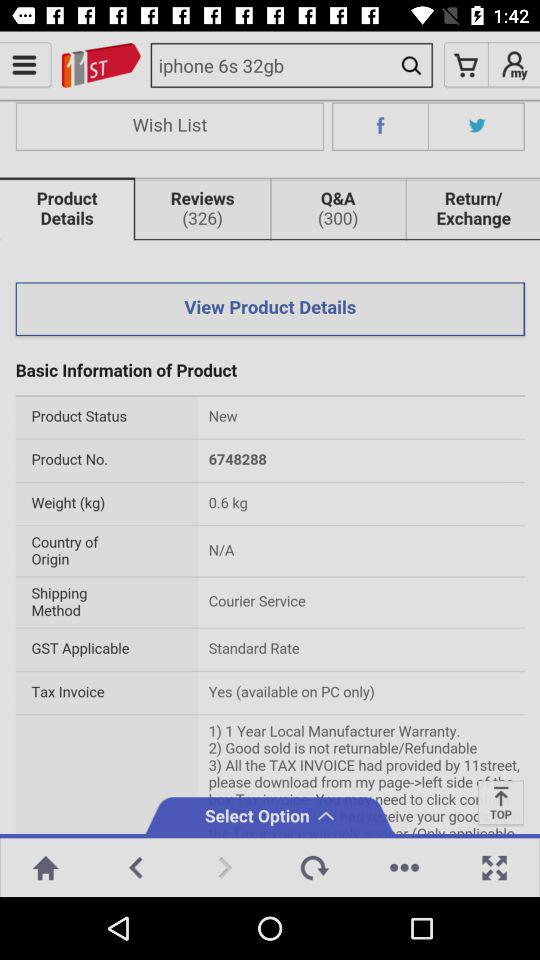Is "Do not show again" checked or unchecked?
Answer the question using a single word or phrase. It is checked. 